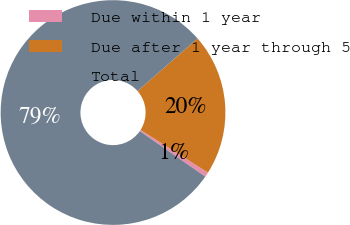Convert chart. <chart><loc_0><loc_0><loc_500><loc_500><pie_chart><fcel>Due within 1 year<fcel>Due after 1 year through 5<fcel>Total<nl><fcel>0.68%<fcel>20.44%<fcel>78.89%<nl></chart> 